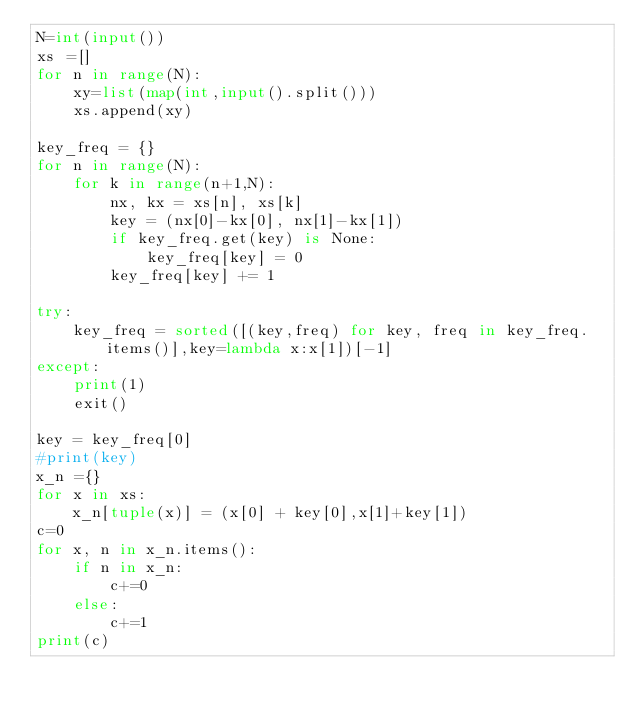Convert code to text. <code><loc_0><loc_0><loc_500><loc_500><_Python_>N=int(input())
xs =[]
for n in range(N):
    xy=list(map(int,input().split()))
    xs.append(xy)

key_freq = {}
for n in range(N):
    for k in range(n+1,N):
        nx, kx = xs[n], xs[k]
        key = (nx[0]-kx[0], nx[1]-kx[1])
        if key_freq.get(key) is None:
            key_freq[key] = 0
        key_freq[key] += 1

try:
    key_freq = sorted([(key,freq) for key, freq in key_freq.items()],key=lambda x:x[1])[-1]
except:
    print(1)
    exit()

key = key_freq[0]
#print(key)
x_n ={}
for x in xs:
    x_n[tuple(x)] = (x[0] + key[0],x[1]+key[1])
c=0
for x, n in x_n.items():
    if n in x_n:
        c+=0
    else:
        c+=1
print(c)</code> 